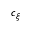Convert formula to latex. <formula><loc_0><loc_0><loc_500><loc_500>c _ { \xi }</formula> 